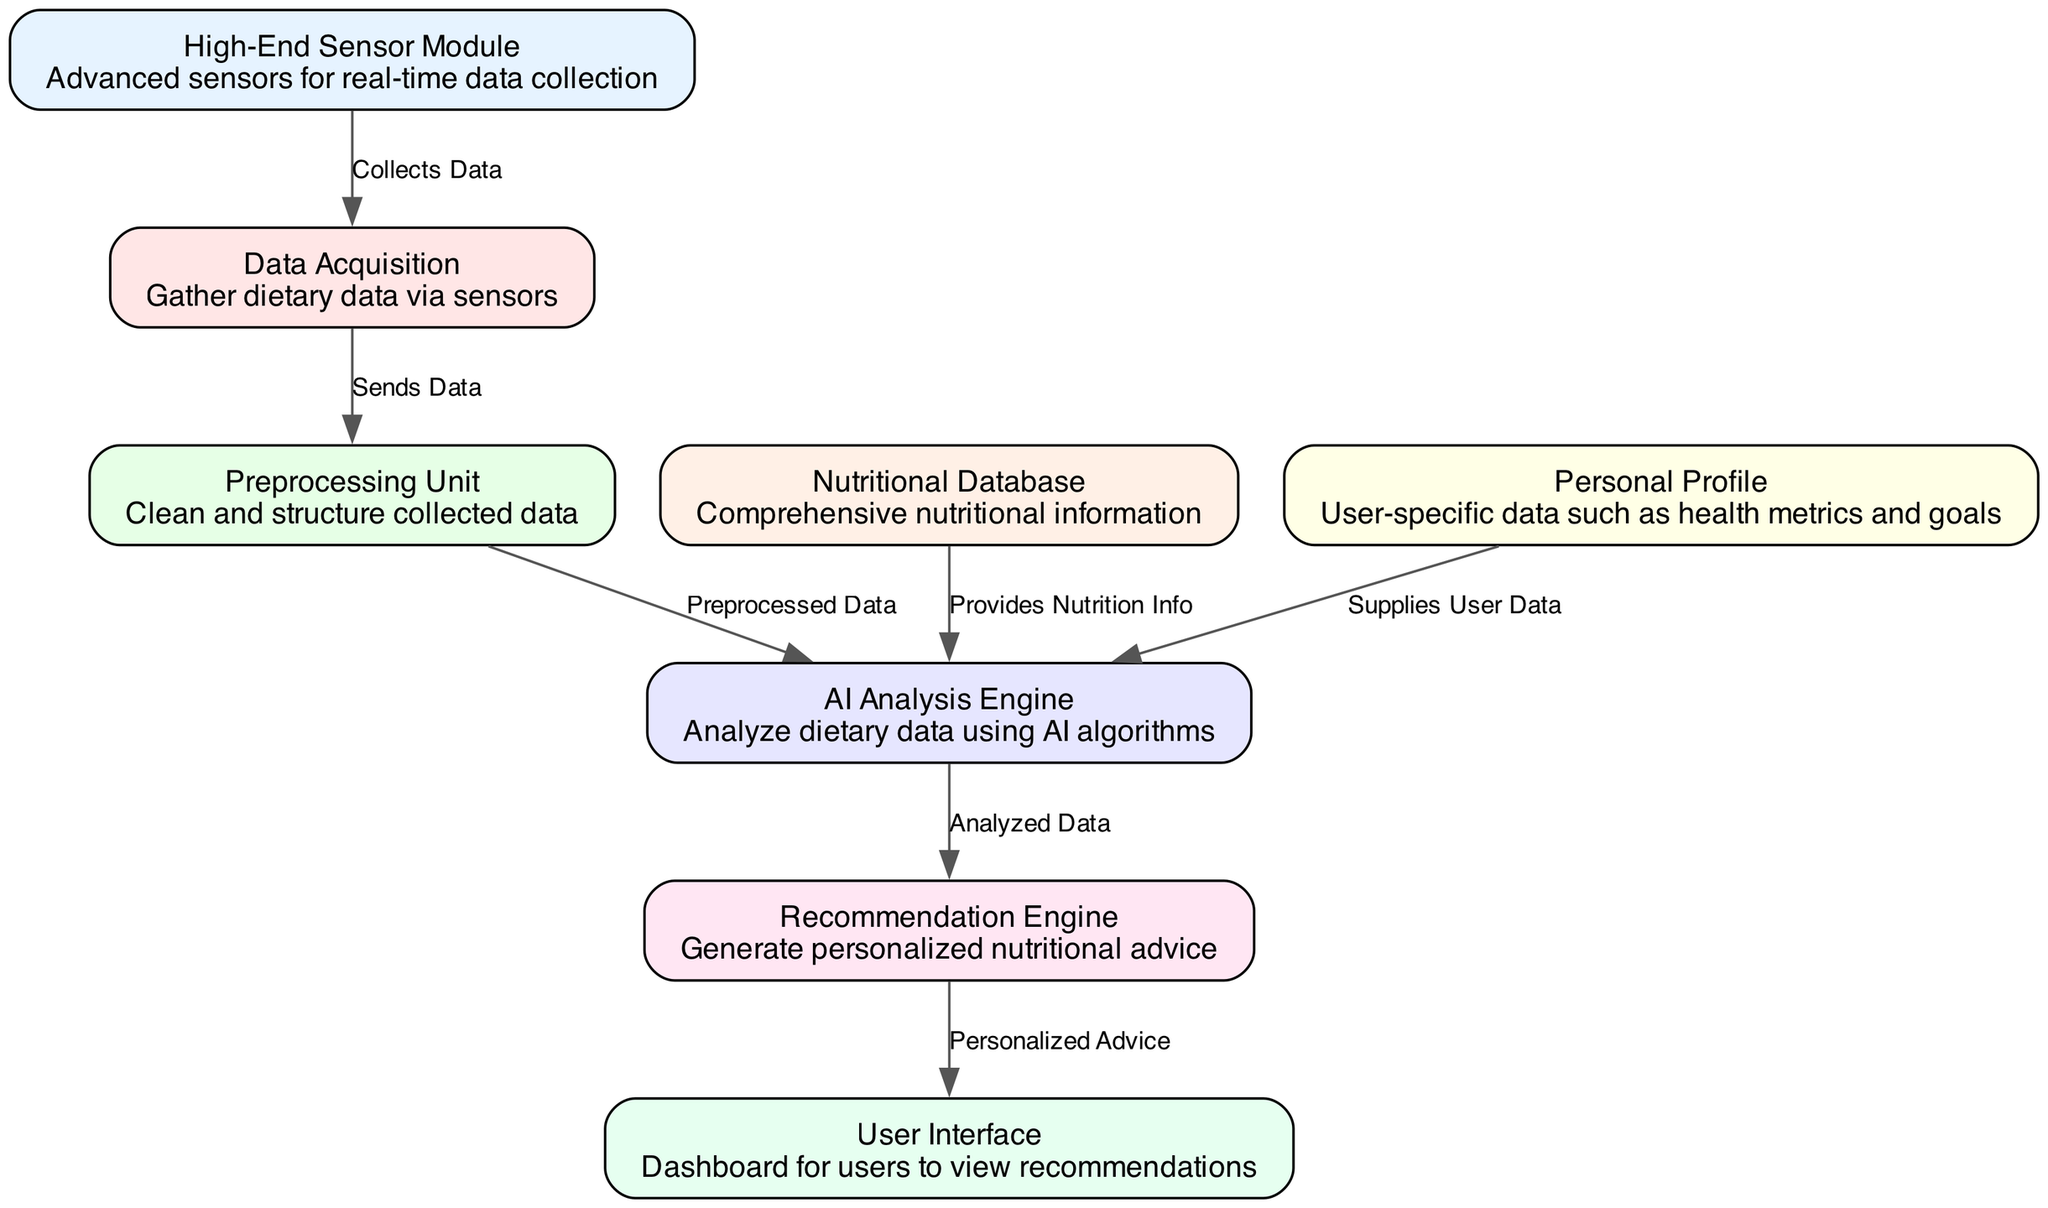What's the label of the node that collects data? The node that collects data is labeled "Data Acquisition". This can be identified by looking for the node that directly follows the "High-End Sensor Module" and is responsible for gathering dietary data.
Answer: Data Acquisition How many nodes are in the diagram? By counting the nodes listed in the data, there are a total of eight nodes depicted in the diagram.
Answer: Eight What does the recommendation engine generate? The recommendation engine is labeled as generating "Personalized Advice", which is noted in the directed flow connecting it to the user interface.
Answer: Personalized Advice What is the relationship between the AI Analysis Engine and the Recommendation Engine? The relationship is that the AI Analysis Engine sends "Analyzed Data" to the Recommendation Engine, which shows how the output of one component informs the next in the diagram's flow.
Answer: Analyzed Data Which node provides nutrition information to the AI Analysis Engine? The "Nutritional Database" provides nutrition information to the AI Analysis Engine, as indicated by the edge that points from the nutritional database to the AI analysis engine with the label "Provides Nutrition Info".
Answer: Nutritional Database How does the data flow from the high-end sensor module to the user interface? The data flow starts at the "High-End Sensor Module", which collects data and sends it to "Data Acquisition". It then goes to the "Preprocessing Unit", which cleans and structures the data, after which it's forwarded to the "AI Analysis Engine". That engine uses the data to create analyzed results that are sent to the "Recommendation Engine". Finally, the recommendation engine directs personalized advice to the "User Interface". Thus, the flow is High-End Sensor Module → Data Acquisition → Preprocessing Unit → AI Analysis Engine → Recommendation Engine → User Interface.
Answer: High-End Sensor Module → User Interface What specific data does the personal profile node supply? The personal profile node supplies "User Data", which includes user-specific health metrics and goals. This is directly connected to the AI Analysis Engine, indicating user-specific customization in the analysis process.
Answer: User Data What is the purpose of the preprocessing unit? The preprocessing unit's purpose is to "Clean and structure collected data", which is an essential step for preparing raw data before further analysis in the AI Analysis Engine.
Answer: Clean and structure collected data What type of analysis does the AI Analysis Engine perform? The AI Analysis Engine performs "Analyze dietary data using AI algorithms", which indicates its function in interpreting and processing the dietary data it receives from the preprocessing unit and personal profile.
Answer: Analyze dietary data using AI algorithms 